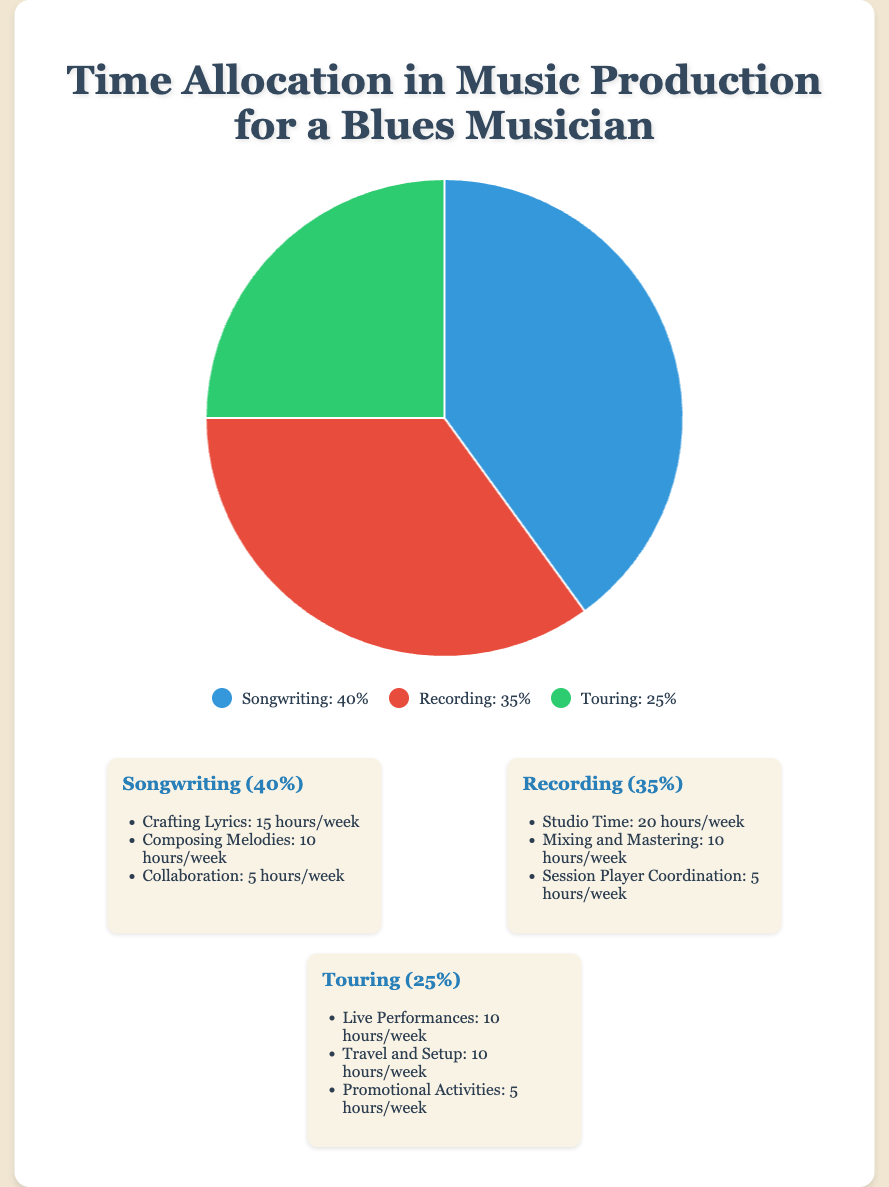What are the three main aspects of music production shown in the pie chart? The pie chart shows three main aspects: Songwriting, Recording, and Touring. These aspects are labeled in the pie chart sections.
Answer: Songwriting, Recording, Touring Which aspect of music production has the highest percentage of time allocation? By looking at the pie chart, the largest section is labeled "Songwriting," which indicates the highest percentage allocation.
Answer: Songwriting How does the percentage of time spent on Recording compare to Songwriting? Songwriting takes 40% of the time, while Recording takes 35%. By comparing these values, we can see that Songwriting has a higher percentage.
Answer: Songwriting has a higher percentage What is the combined percentage of time spent on Recording and Touring? Recording takes 35% and Touring takes 25%. Adding these together gives 35% + 25% = 60%.
Answer: 60% If you spent an additional 10% of your time on Songwriting and decreased Recording by 10%, what would the new percentages be? Initially, Songwriting and Recording are at 40% and 35%, respectively. Adding 10% to Songwriting and subtracting 10% from Recording results in new values: Songwriting 50% and Recording 25%.
Answer: Songwriting 50%, Recording 25% Which aspect takes up more time: Crafting Lyrics or Studio Time? From the details, Crafting Lyrics takes 15 hours per week, whereas Studio Time takes 20 hours per week. By comparing these values, Studio Time is higher.
Answer: Studio Time What is the total number of hours spent per week on Songwriting activities? Summing up the hours for Crafting Lyrics (15), Composing Melodies (10), and Collaboration (5), the total is 15 + 10 + 5 = 30 hours per week.
Answer: 30 hours per week If you reduced time spent on Travel and Setup by half, how many hours per week would that be? The current time for Travel and Setup is 10 hours per week. Halving this amount gives 10 / 2 = 5 hours per week.
Answer: 5 hours per week What visual color represents the Touring aspect in the chart? In the pie chart, the section corresponding to Touring is represented by the color green.
Answer: green How many hours per week are spent on Mixing and Mastering combined with Promotional Activities? Mixing and Mastering takes 10 hours per week, and Promotional Activities take 5 hours per week. Adding these gives 10 + 5 = 15 hours per week.
Answer: 15 hours per week 